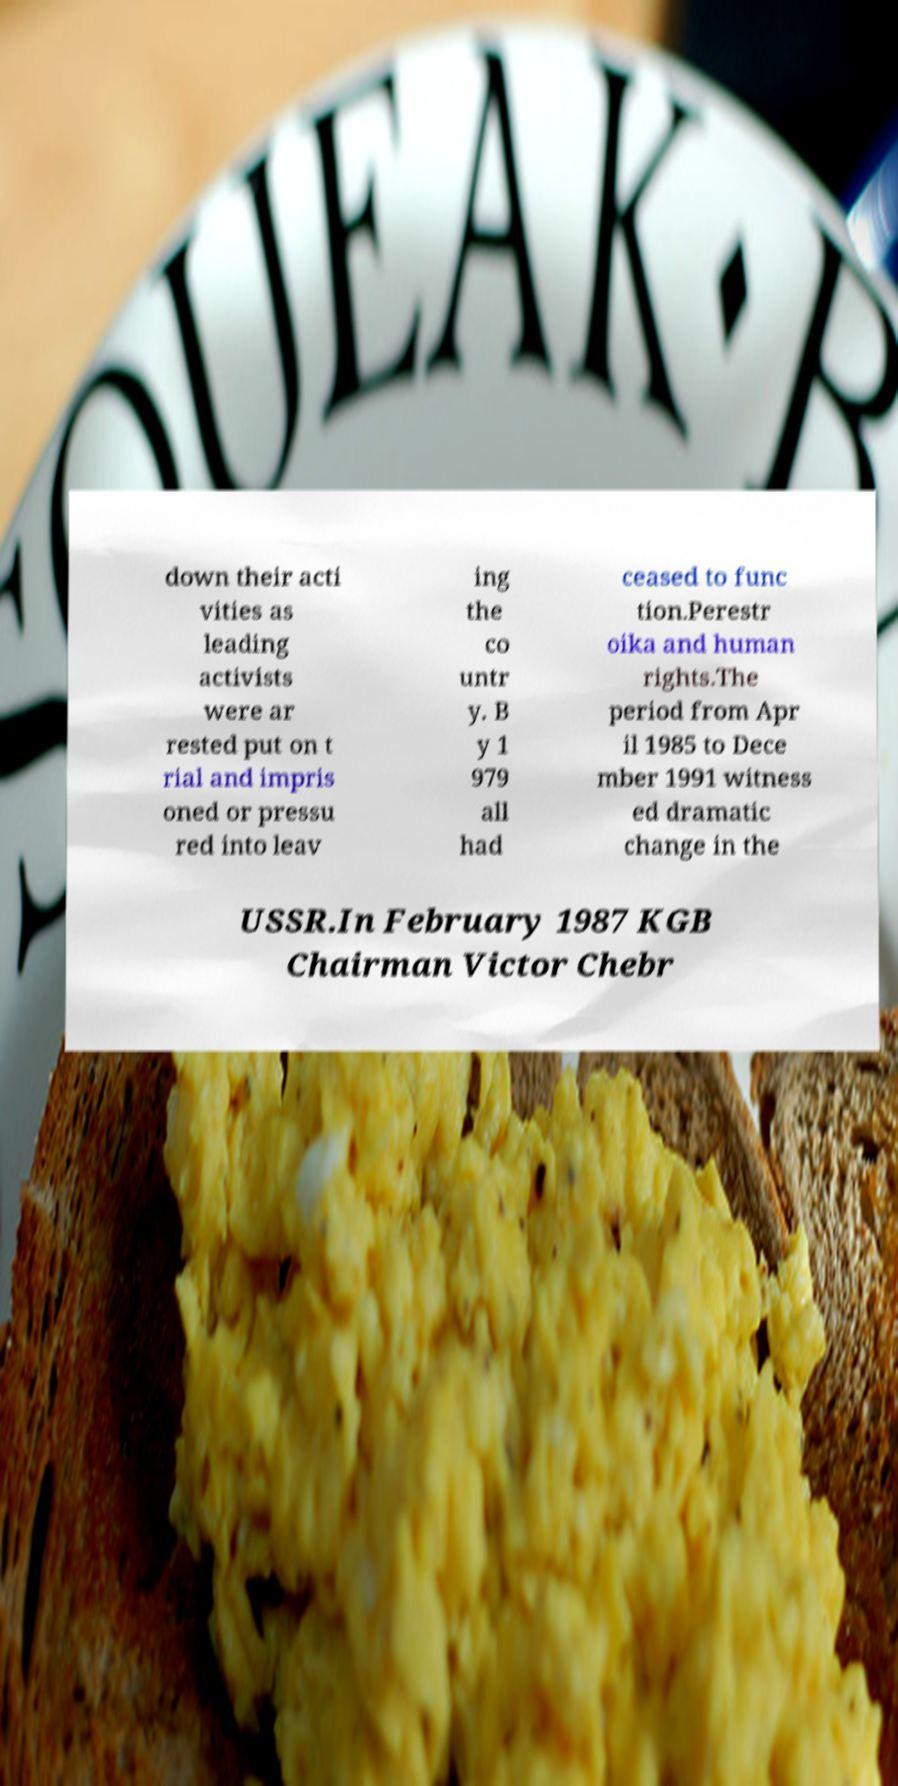Please identify and transcribe the text found in this image. down their acti vities as leading activists were ar rested put on t rial and impris oned or pressu red into leav ing the co untr y. B y 1 979 all had ceased to func tion.Perestr oika and human rights.The period from Apr il 1985 to Dece mber 1991 witness ed dramatic change in the USSR.In February 1987 KGB Chairman Victor Chebr 